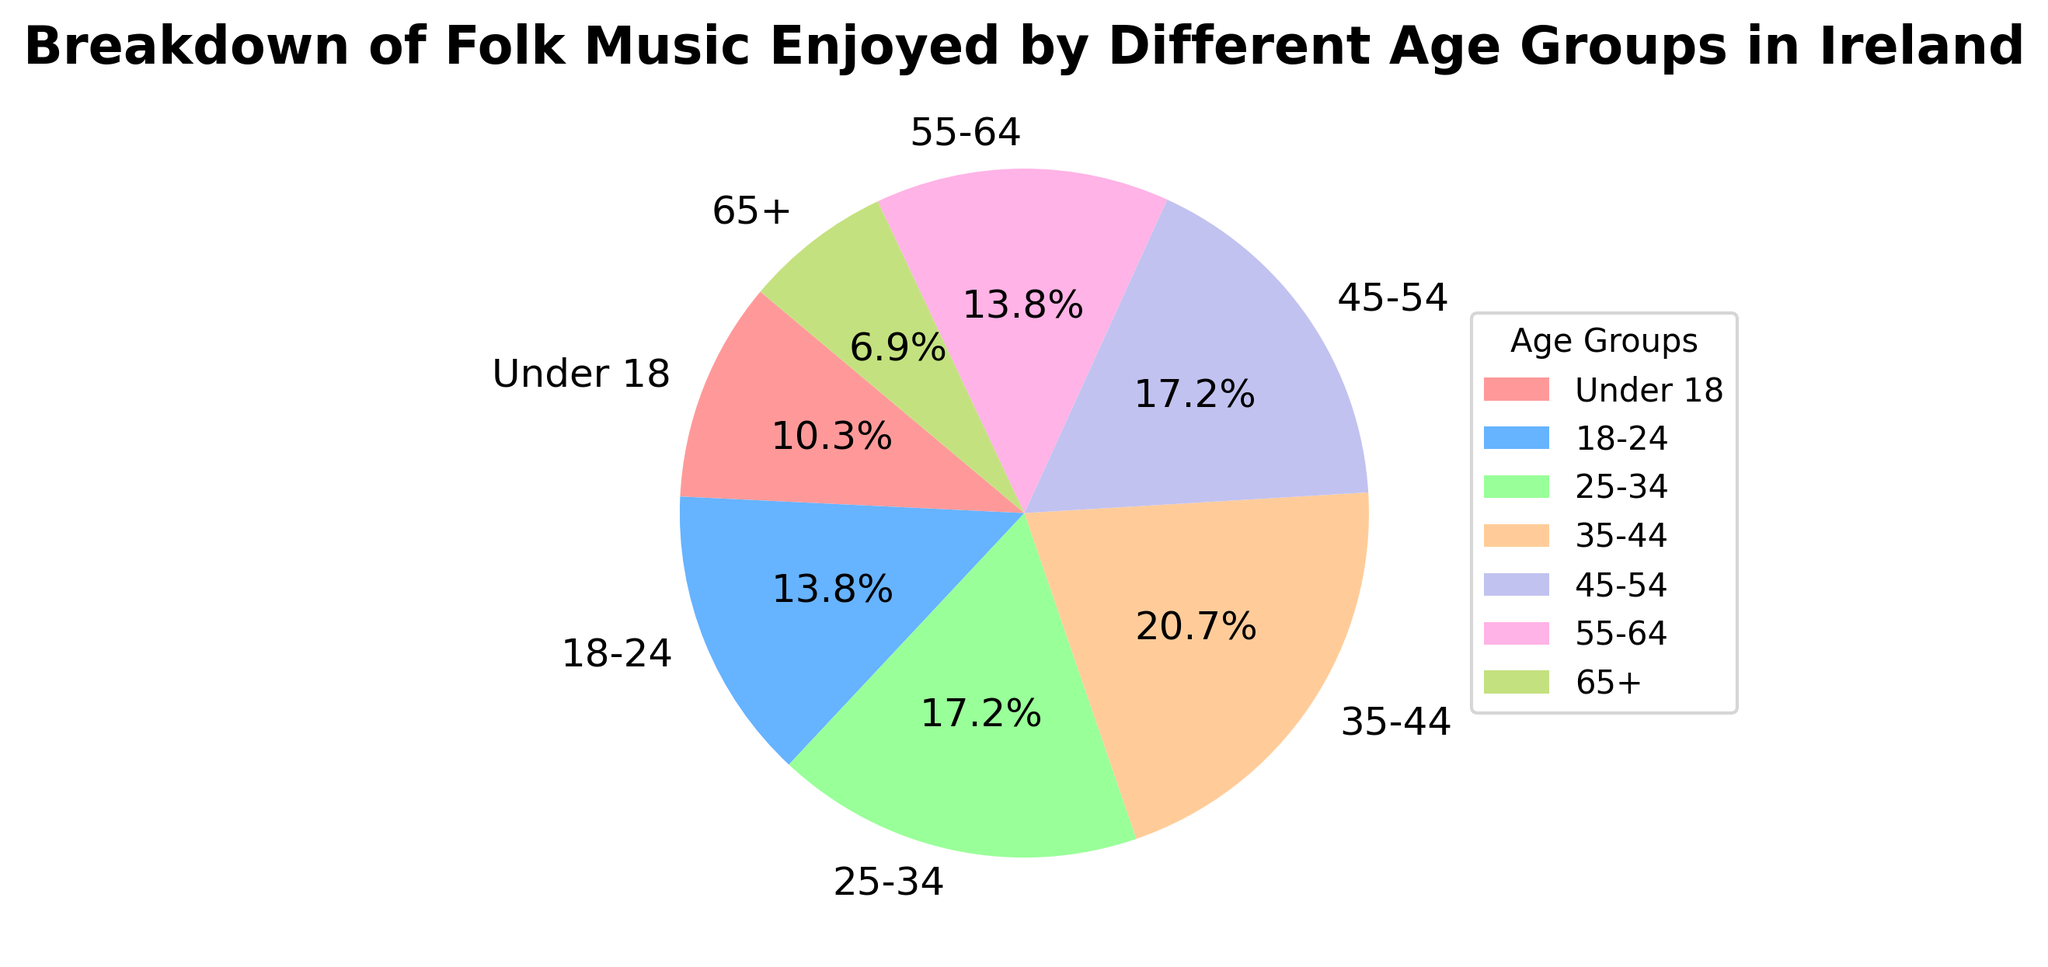What's the most popular age group for folk music enjoyment? From the pie chart, observe the segments and identify which age group occupies the largest portion. The segment labeled "35-44" is the largest.
Answer: 35-44 Which two age groups enjoy folk music equally? Look at the segments and identify age groups that have the same percentage. Both "18-24" and "45-54" have the same segment size (both 25%).
Answer: 18-24 and 45-54 What percentage of the 55-64 age group enjoys folk music? Locate the "55-64" segment in the pie chart and read the percentage label associated with it. The slice labeled "55-64" shows 20%.
Answer: 20% Compare the enjoyment of folk music between the "Under 18" and "65+" age groups. Which group has a higher percentage, and by how much? Identify the segments for both age groups and note their percentages, then calculate the difference. "Under 18" is 15%, and "65+" is 10%, making a difference of 5%.
Answer: Under 18 by 5% What is the combined percentage of folk music enjoyment for the age groups below 25 years? Locate the "Under 18" and "18-24" segments, note their percentages, and add them together: 15% + 20% = 35%.
Answer: 35% What is the median percentage value of folk music enjoyment among all age groups? List the percentages in increasing order: 10%, 10%, 15%, 20%, 25%, 25%, 30%. The median value is the middle number in this list.
Answer: 20% Which age group has the smallest percentage of folk music enjoyment? Scan the pie chart for the smallest segment and read the corresponding label. The smallest percentage (10%) is shared by both "65+" and "55-64".
Answer: 65+ and 55-64 How much more do the age group 35-44 enjoy folk music compared to the age group "Under 18"? Find and compare the percentages for both groups: 35-44 is 30% and "Under 18" is 15%. Subtract the smaller percentage from the larger one: 30% - 15% = 15%.
Answer: 15% What is the difference between the highest and lowest percentages of folk music enjoyment among the age groups? Identify the highest percentage (30%, for 35-44) and the lowest percentage (10%, for 65+ and 55-64) and subtract the lowest from the highest: 30% - 10% = 20%.
Answer: 20% 